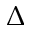Convert formula to latex. <formula><loc_0><loc_0><loc_500><loc_500>\Delta</formula> 